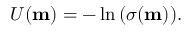Convert formula to latex. <formula><loc_0><loc_0><loc_500><loc_500>\begin{array} { r } { U ( m ) = - \ln { \left ( \sigma ( m ) \right ) } . } \end{array}</formula> 